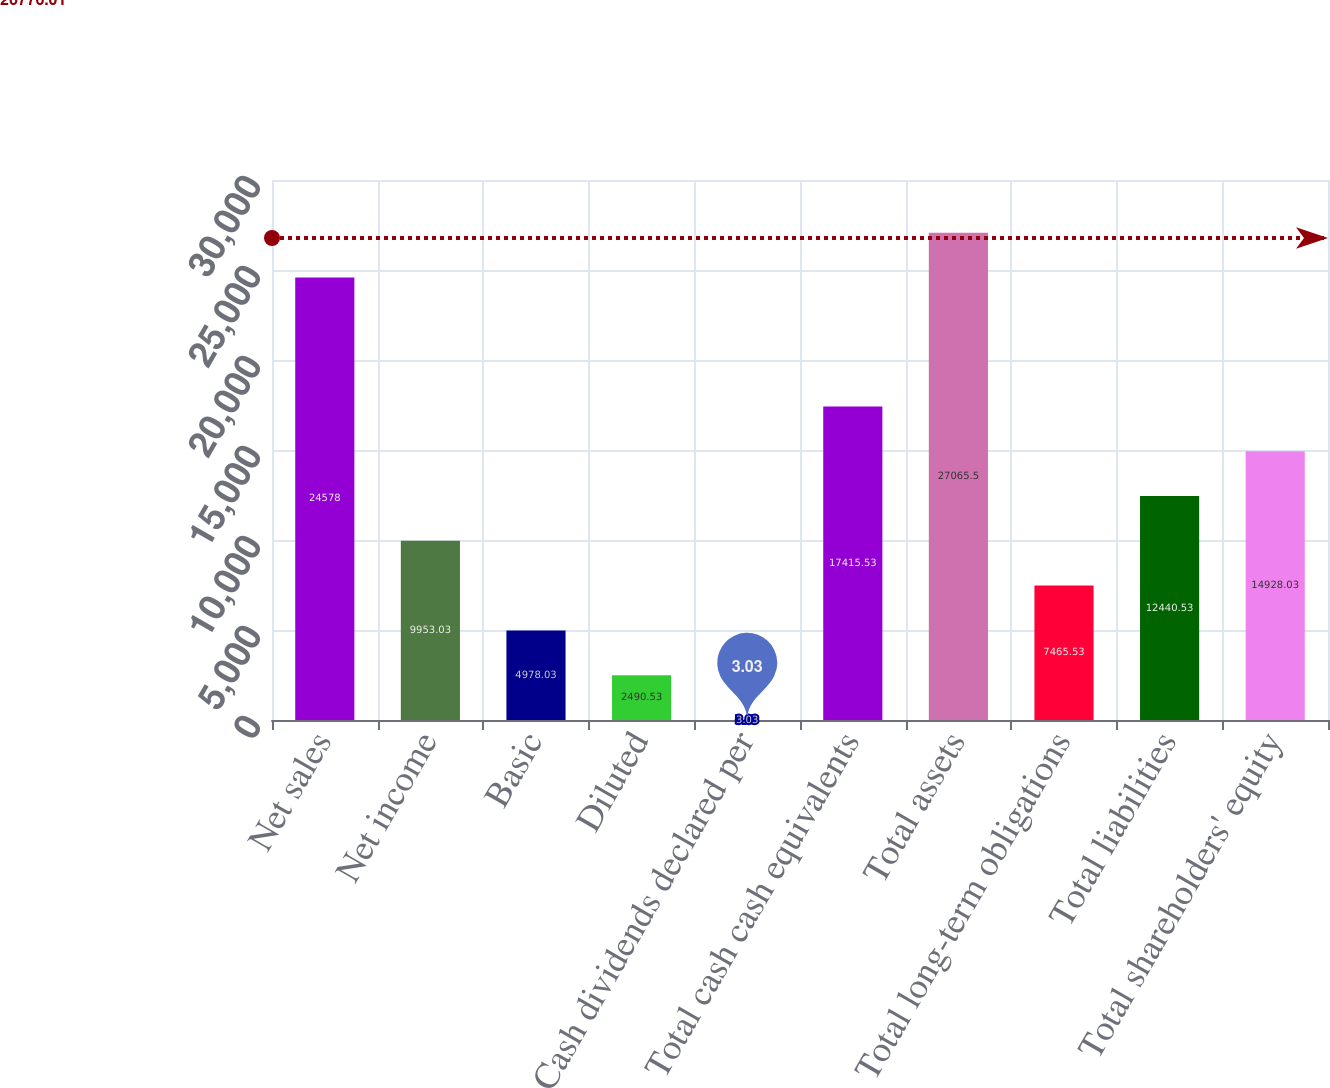<chart> <loc_0><loc_0><loc_500><loc_500><bar_chart><fcel>Net sales<fcel>Net income<fcel>Basic<fcel>Diluted<fcel>Cash dividends declared per<fcel>Total cash cash equivalents<fcel>Total assets<fcel>Total long-term obligations<fcel>Total liabilities<fcel>Total shareholders' equity<nl><fcel>24578<fcel>9953.03<fcel>4978.03<fcel>2490.53<fcel>3.03<fcel>17415.5<fcel>27065.5<fcel>7465.53<fcel>12440.5<fcel>14928<nl></chart> 